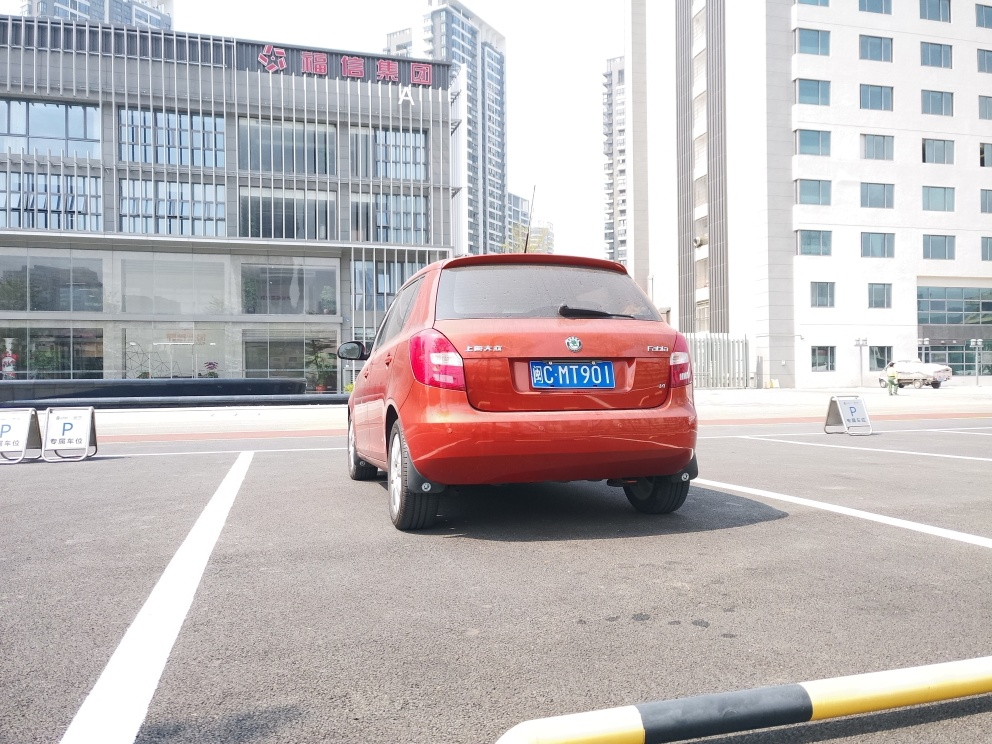Does the image retain most of the texture details? Yes, the image clearly retains the texture details of various elements, such as the smooth finish of the car's exterior, the grainy asphalt of the parking lot, and the reflections in the windows of the buildings in the background. Even the smaller details like the text and symbols on the car's license plate and the parking signage are discernible. 